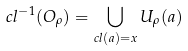Convert formula to latex. <formula><loc_0><loc_0><loc_500><loc_500>c l ^ { - 1 } ( O _ { \rho } ) = \bigcup _ { c l ( a ) = x } U _ { \rho } ( a )</formula> 